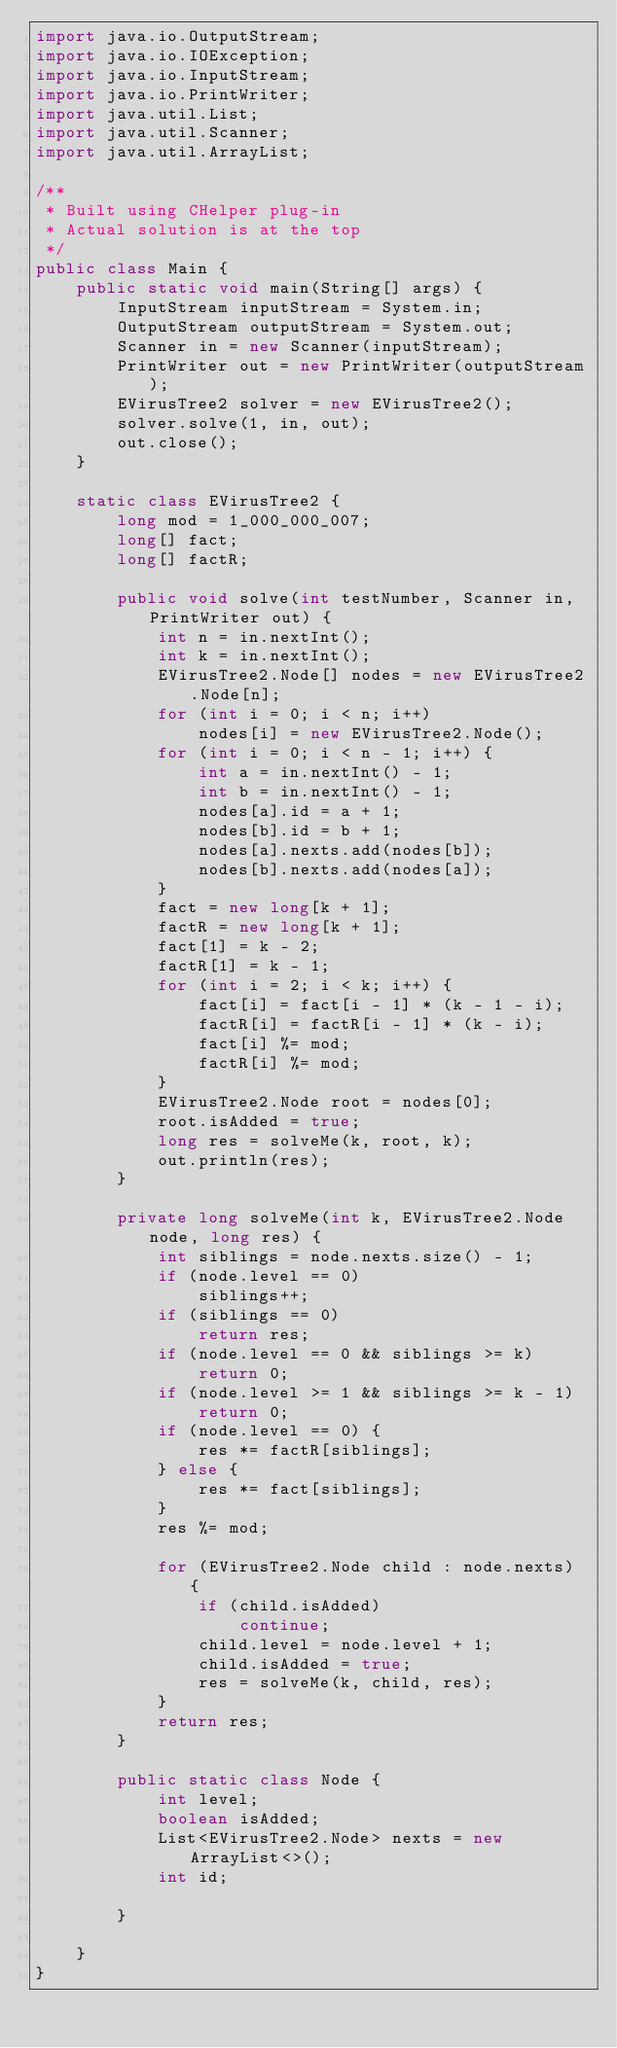<code> <loc_0><loc_0><loc_500><loc_500><_Java_>import java.io.OutputStream;
import java.io.IOException;
import java.io.InputStream;
import java.io.PrintWriter;
import java.util.List;
import java.util.Scanner;
import java.util.ArrayList;

/**
 * Built using CHelper plug-in
 * Actual solution is at the top
 */
public class Main {
    public static void main(String[] args) {
        InputStream inputStream = System.in;
        OutputStream outputStream = System.out;
        Scanner in = new Scanner(inputStream);
        PrintWriter out = new PrintWriter(outputStream);
        EVirusTree2 solver = new EVirusTree2();
        solver.solve(1, in, out);
        out.close();
    }

    static class EVirusTree2 {
        long mod = 1_000_000_007;
        long[] fact;
        long[] factR;

        public void solve(int testNumber, Scanner in, PrintWriter out) {
            int n = in.nextInt();
            int k = in.nextInt();
            EVirusTree2.Node[] nodes = new EVirusTree2.Node[n];
            for (int i = 0; i < n; i++)
                nodes[i] = new EVirusTree2.Node();
            for (int i = 0; i < n - 1; i++) {
                int a = in.nextInt() - 1;
                int b = in.nextInt() - 1;
                nodes[a].id = a + 1;
                nodes[b].id = b + 1;
                nodes[a].nexts.add(nodes[b]);
                nodes[b].nexts.add(nodes[a]);
            }
            fact = new long[k + 1];
            factR = new long[k + 1];
            fact[1] = k - 2;
            factR[1] = k - 1;
            for (int i = 2; i < k; i++) {
                fact[i] = fact[i - 1] * (k - 1 - i);
                factR[i] = factR[i - 1] * (k - i);
                fact[i] %= mod;
                factR[i] %= mod;
            }
            EVirusTree2.Node root = nodes[0];
            root.isAdded = true;
            long res = solveMe(k, root, k);
            out.println(res);
        }

        private long solveMe(int k, EVirusTree2.Node node, long res) {
            int siblings = node.nexts.size() - 1;
            if (node.level == 0)
                siblings++;
            if (siblings == 0)
                return res;
            if (node.level == 0 && siblings >= k)
                return 0;
            if (node.level >= 1 && siblings >= k - 1)
                return 0;
            if (node.level == 0) {
                res *= factR[siblings];
            } else {
                res *= fact[siblings];
            }
            res %= mod;

            for (EVirusTree2.Node child : node.nexts) {
                if (child.isAdded)
                    continue;
                child.level = node.level + 1;
                child.isAdded = true;
                res = solveMe(k, child, res);
            }
            return res;
        }

        public static class Node {
            int level;
            boolean isAdded;
            List<EVirusTree2.Node> nexts = new ArrayList<>();
            int id;

        }

    }
}

</code> 